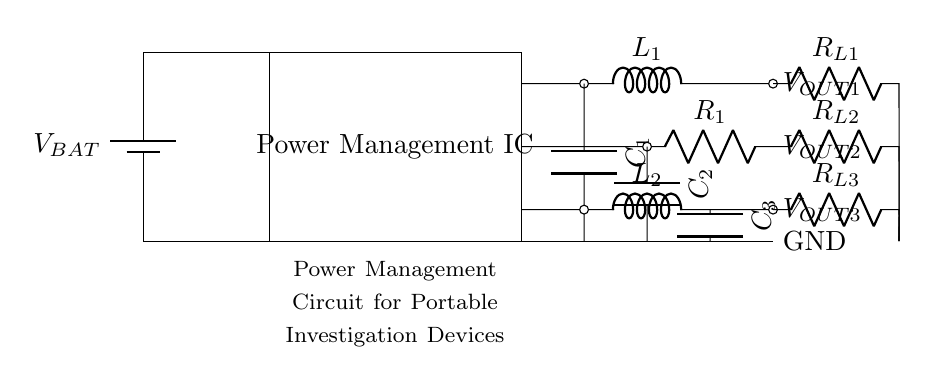What is the function of the battery? The battery serves as a power source, providing the necessary voltage to operate the circuit. It is located on the left side of the diagram, and its label indicates its voltage level as \(V_{BAT}\).
Answer: Power source What are the output voltages from the circuit? The circuit has three output voltages: \(V_{OUT1}\), \(V_{OUT2}\), and \(V_{OUT3}\). These output voltages are connected to different components, showing the voltage provided to each load connected to the power management IC.
Answer: \(V_{OUT1}, V_{OUT2}, V_{OUT3}\) What type of converter is used for \(V_{OUT1}\)? The circuit uses a buck converter for \(V_{OUT1}\). This is indicated by the inductor \(L_1\) connected with a capacitor in the path leading to \(V_{OUT1}\), demonstrating a step-down voltage conversion process.
Answer: Buck converter Which component regulates the voltage for \(V_{OUT2}\)? The voltage for \(V_{OUT2}\) is regulated by an LDO (Low Drop-Out) regulator. In the diagram, this is shown by the resistor \(R_1\) following the connection from the power management IC, which indicates voltage regulation.
Answer: LDO How many loads are connected in total in this circuit? There are three loads connected in the circuit, labeled as \(R_{L1}\), \(R_{L2}\), and \(R_{L3}\). The labels on the right side of the circuit clearly indicate the resistors used as loads for the respective output voltages.
Answer: Three loads What determines the boost converter's output voltage? The output voltage of the boost converter, \(V_{OUT3}\), is determined by the inductor \(L_2\) and capacitor \(C_3\) in its circuit path, which is designed to step up the input voltage to a higher level. This is reflected in the connections made from the power management IC.
Answer: Inductor and capacitor 